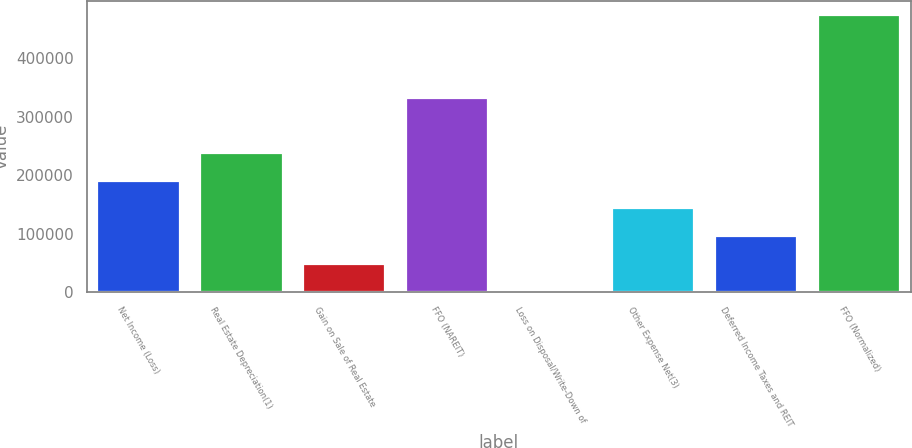Convert chart. <chart><loc_0><loc_0><loc_500><loc_500><bar_chart><fcel>Net Income (Loss)<fcel>Real Estate Depreciation(1)<fcel>Gain on Sale of Real Estate<fcel>FFO (NAREIT)<fcel>Loss on Disposal/Write-Down of<fcel>Other Expense Net(3)<fcel>Deferred Income Taxes and REIT<fcel>FFO (Normalized)<nl><fcel>190315<fcel>237541<fcel>48637.8<fcel>331311<fcel>1412<fcel>143089<fcel>95863.6<fcel>473670<nl></chart> 